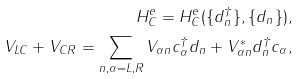Convert formula to latex. <formula><loc_0><loc_0><loc_500><loc_500>H _ { C } ^ { e } = H _ { C } ^ { e } ( \{ d ^ { \dag } _ { n } \} , \{ d _ { n } \} ) , \\ V _ { L C } + V _ { C R } = \sum _ { n , \alpha = L , R } V _ { \alpha n } c ^ { \dag } _ { \alpha } d _ { n } + V ^ { * } _ { \alpha n } d ^ { \dag } _ { n } c _ { \alpha } ,</formula> 